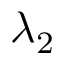<formula> <loc_0><loc_0><loc_500><loc_500>\lambda _ { 2 }</formula> 